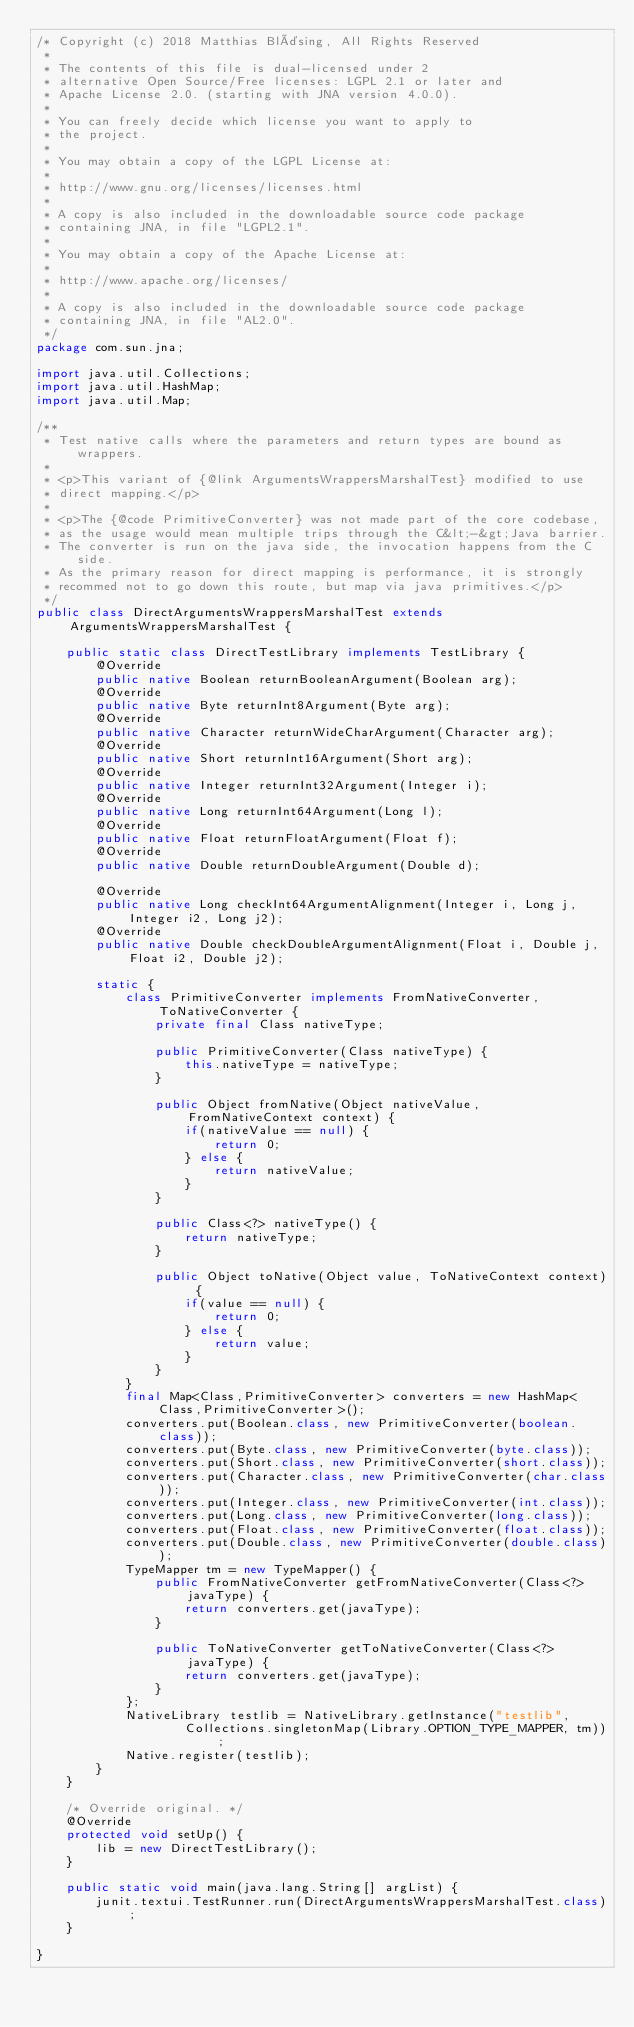Convert code to text. <code><loc_0><loc_0><loc_500><loc_500><_Java_>/* Copyright (c) 2018 Matthias Bläsing, All Rights Reserved
 *
 * The contents of this file is dual-licensed under 2
 * alternative Open Source/Free licenses: LGPL 2.1 or later and
 * Apache License 2.0. (starting with JNA version 4.0.0).
 *
 * You can freely decide which license you want to apply to
 * the project.
 *
 * You may obtain a copy of the LGPL License at:
 *
 * http://www.gnu.org/licenses/licenses.html
 *
 * A copy is also included in the downloadable source code package
 * containing JNA, in file "LGPL2.1".
 *
 * You may obtain a copy of the Apache License at:
 *
 * http://www.apache.org/licenses/
 *
 * A copy is also included in the downloadable source code package
 * containing JNA, in file "AL2.0".
 */
package com.sun.jna;

import java.util.Collections;
import java.util.HashMap;
import java.util.Map;

/**
 * Test native calls where the parameters and return types are bound as wrappers.
 *
 * <p>This variant of {@link ArgumentsWrappersMarshalTest} modified to use
 * direct mapping.</p>
 *
 * <p>The {@code PrimitiveConverter} was not made part of the core codebase,
 * as the usage would mean multiple trips through the C&lt;-&gt;Java barrier.
 * The converter is run on the java side, the invocation happens from the C side.
 * As the primary reason for direct mapping is performance, it is strongly
 * recommed not to go down this route, but map via java primitives.</p>
 */
public class DirectArgumentsWrappersMarshalTest extends ArgumentsWrappersMarshalTest {

    public static class DirectTestLibrary implements TestLibrary {
        @Override
        public native Boolean returnBooleanArgument(Boolean arg);
        @Override
        public native Byte returnInt8Argument(Byte arg);
        @Override
        public native Character returnWideCharArgument(Character arg);
        @Override
        public native Short returnInt16Argument(Short arg);
        @Override
        public native Integer returnInt32Argument(Integer i);
        @Override
        public native Long returnInt64Argument(Long l);
        @Override
        public native Float returnFloatArgument(Float f);
        @Override
        public native Double returnDoubleArgument(Double d);

        @Override
        public native Long checkInt64ArgumentAlignment(Integer i, Long j, Integer i2, Long j2);
        @Override
        public native Double checkDoubleArgumentAlignment(Float i, Double j, Float i2, Double j2);

        static {
            class PrimitiveConverter implements FromNativeConverter, ToNativeConverter {
                private final Class nativeType;

                public PrimitiveConverter(Class nativeType) {
                    this.nativeType = nativeType;
                }

                public Object fromNative(Object nativeValue, FromNativeContext context) {
                    if(nativeValue == null) {
                        return 0;
                    } else {
                        return nativeValue;
                    }
                }

                public Class<?> nativeType() {
                    return nativeType;
                }

                public Object toNative(Object value, ToNativeContext context) {
                    if(value == null) {
                        return 0;
                    } else {
                        return value;
                    }
                }
            }
            final Map<Class,PrimitiveConverter> converters = new HashMap<Class,PrimitiveConverter>();
            converters.put(Boolean.class, new PrimitiveConverter(boolean.class));
            converters.put(Byte.class, new PrimitiveConverter(byte.class));
            converters.put(Short.class, new PrimitiveConverter(short.class));
            converters.put(Character.class, new PrimitiveConverter(char.class));
            converters.put(Integer.class, new PrimitiveConverter(int.class));
            converters.put(Long.class, new PrimitiveConverter(long.class));
            converters.put(Float.class, new PrimitiveConverter(float.class));
            converters.put(Double.class, new PrimitiveConverter(double.class));
            TypeMapper tm = new TypeMapper() {
                public FromNativeConverter getFromNativeConverter(Class<?> javaType) {
                    return converters.get(javaType);
                }

                public ToNativeConverter getToNativeConverter(Class<?> javaType) {
                    return converters.get(javaType);
                }
            };
            NativeLibrary testlib = NativeLibrary.getInstance("testlib",
                    Collections.singletonMap(Library.OPTION_TYPE_MAPPER, tm));
            Native.register(testlib);
        }
    }

    /* Override original. */
    @Override
    protected void setUp() {
        lib = new DirectTestLibrary();
    }

    public static void main(java.lang.String[] argList) {
        junit.textui.TestRunner.run(DirectArgumentsWrappersMarshalTest.class);
    }

}
</code> 